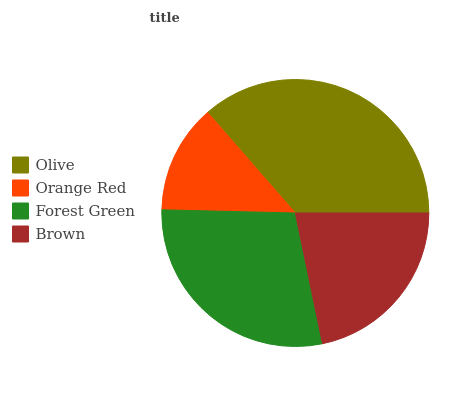Is Orange Red the minimum?
Answer yes or no. Yes. Is Olive the maximum?
Answer yes or no. Yes. Is Forest Green the minimum?
Answer yes or no. No. Is Forest Green the maximum?
Answer yes or no. No. Is Forest Green greater than Orange Red?
Answer yes or no. Yes. Is Orange Red less than Forest Green?
Answer yes or no. Yes. Is Orange Red greater than Forest Green?
Answer yes or no. No. Is Forest Green less than Orange Red?
Answer yes or no. No. Is Forest Green the high median?
Answer yes or no. Yes. Is Brown the low median?
Answer yes or no. Yes. Is Brown the high median?
Answer yes or no. No. Is Olive the low median?
Answer yes or no. No. 